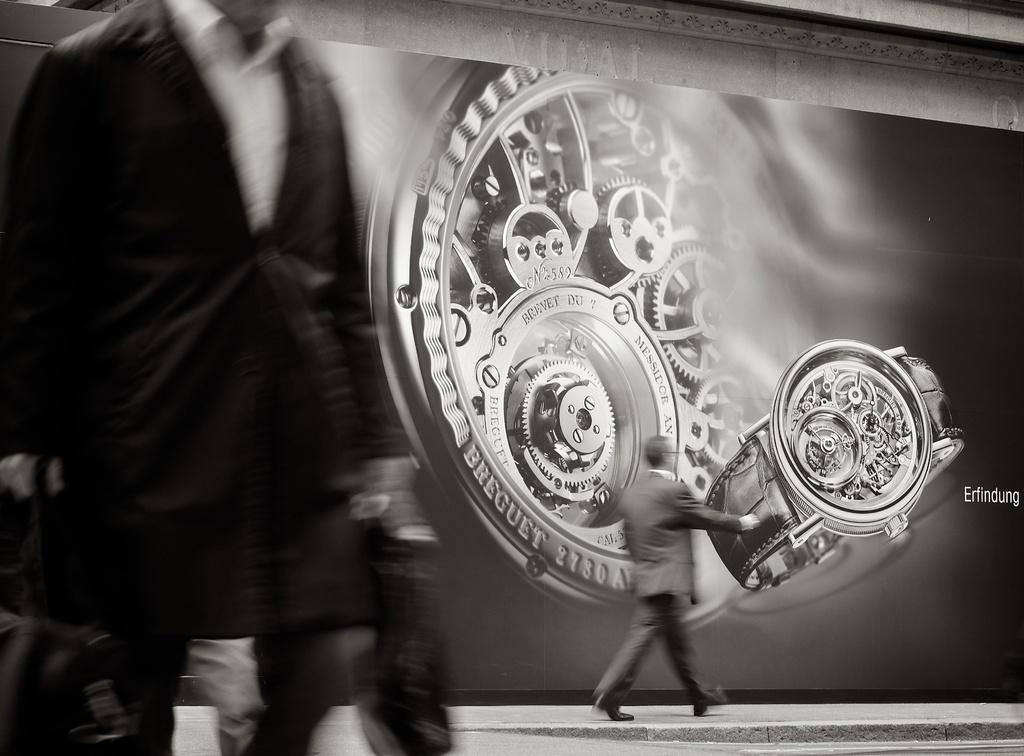What does it say next to the watch on the ad?
Ensure brevity in your answer.  Erfindung. What word is shown on the watch rim?
Your answer should be very brief. Breguet. 